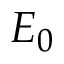<formula> <loc_0><loc_0><loc_500><loc_500>E _ { 0 }</formula> 